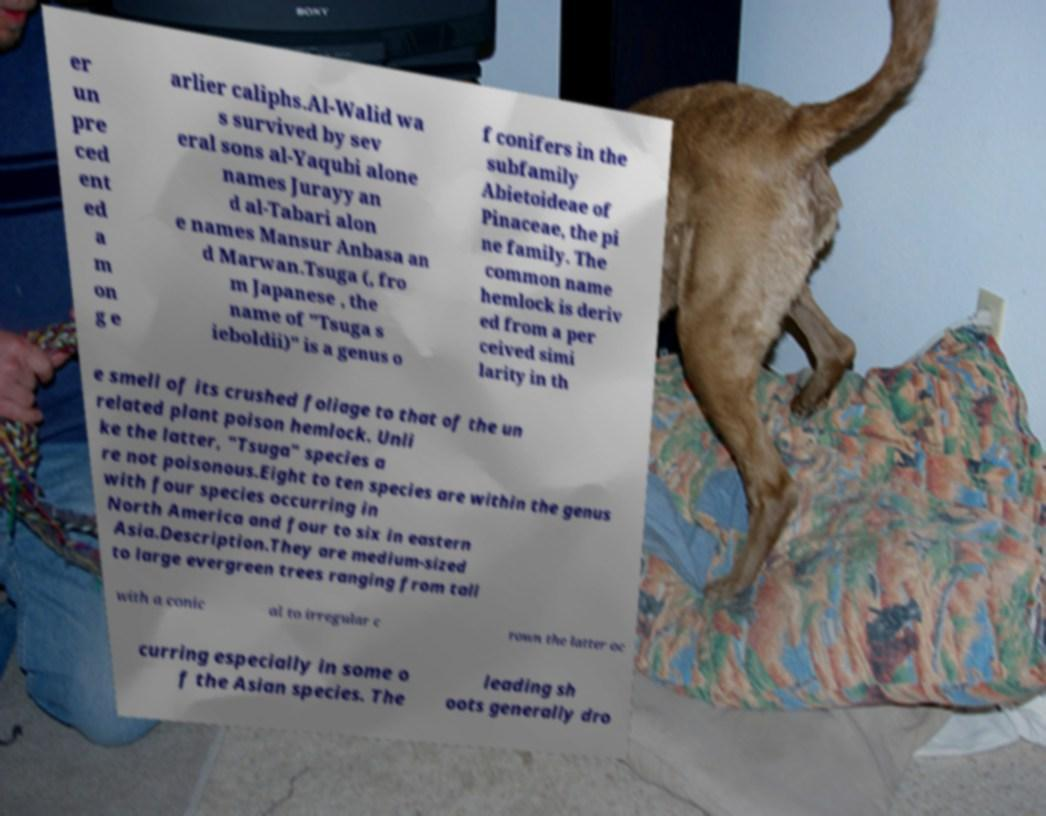For documentation purposes, I need the text within this image transcribed. Could you provide that? er un pre ced ent ed a m on g e arlier caliphs.Al-Walid wa s survived by sev eral sons al-Yaqubi alone names Jurayy an d al-Tabari alon e names Mansur Anbasa an d Marwan.Tsuga (, fro m Japanese , the name of "Tsuga s ieboldii)" is a genus o f conifers in the subfamily Abietoideae of Pinaceae, the pi ne family. The common name hemlock is deriv ed from a per ceived simi larity in th e smell of its crushed foliage to that of the un related plant poison hemlock. Unli ke the latter, "Tsuga" species a re not poisonous.Eight to ten species are within the genus with four species occurring in North America and four to six in eastern Asia.Description.They are medium-sized to large evergreen trees ranging from tall with a conic al to irregular c rown the latter oc curring especially in some o f the Asian species. The leading sh oots generally dro 